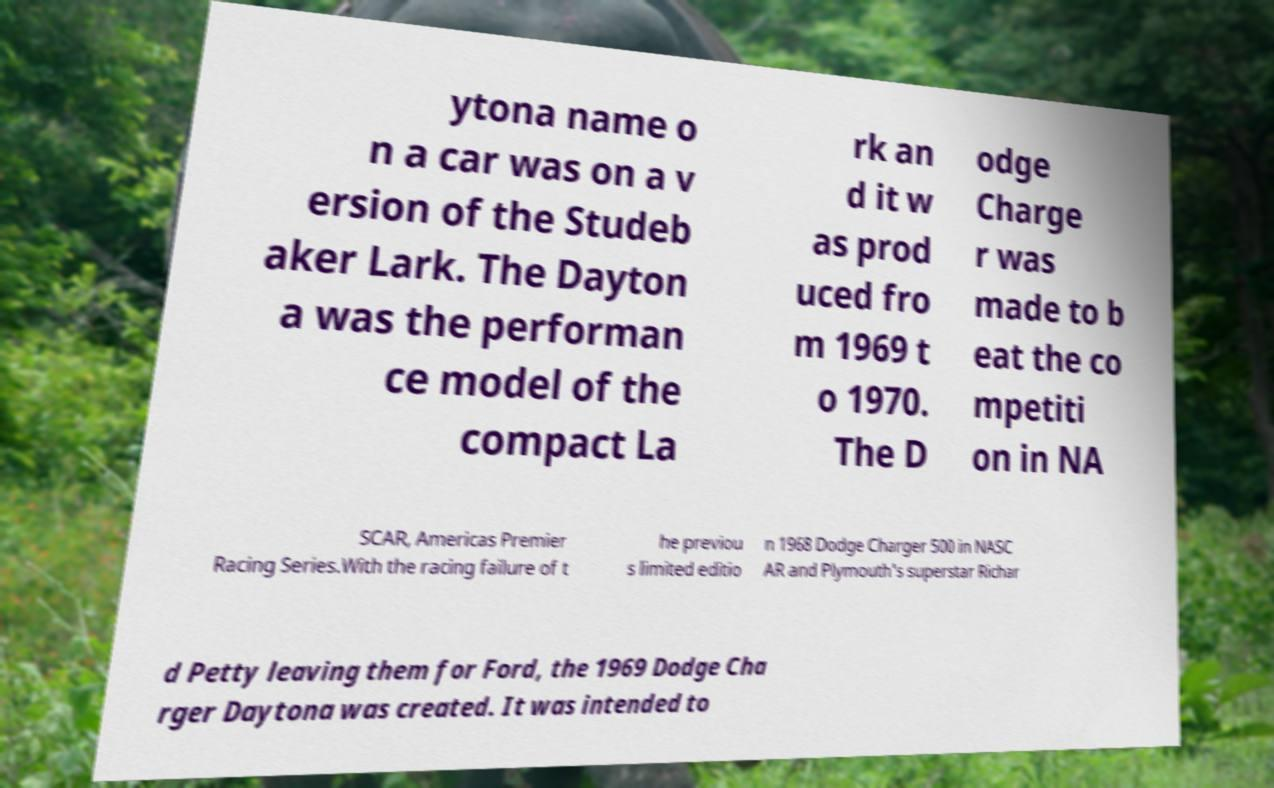Can you accurately transcribe the text from the provided image for me? ytona name o n a car was on a v ersion of the Studeb aker Lark. The Dayton a was the performan ce model of the compact La rk an d it w as prod uced fro m 1969 t o 1970. The D odge Charge r was made to b eat the co mpetiti on in NA SCAR, Americas Premier Racing Series.With the racing failure of t he previou s limited editio n 1968 Dodge Charger 500 in NASC AR and Plymouth's superstar Richar d Petty leaving them for Ford, the 1969 Dodge Cha rger Daytona was created. It was intended to 